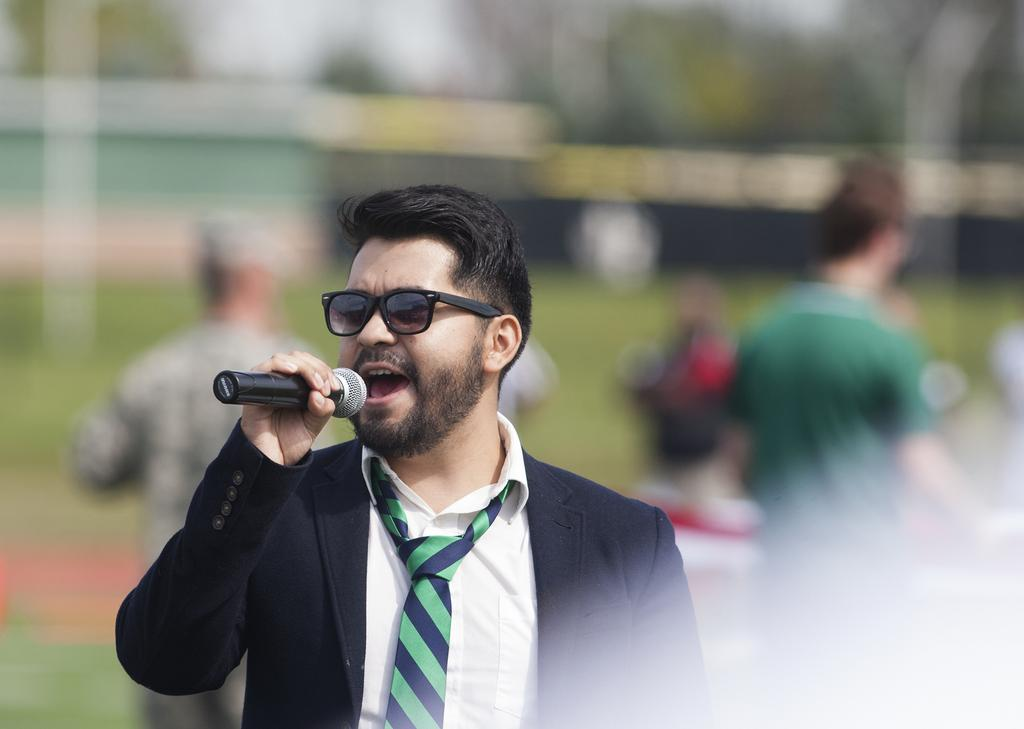What is the main subject of the image? There is a person in the image. What is the person wearing? The person is wearing a black suit and black goggles. What is the person holding in the image? The person is holding a microphone. What can be seen in the background of the image? There are people walking in the background of the image. How much fear is present in the image? There is no indication of fear in the image; it simply shows a person holding a microphone and people walking in the background. Is there a window visible in the image? There is no mention of a window in the provided facts, so we cannot determine if one is present in the image. 